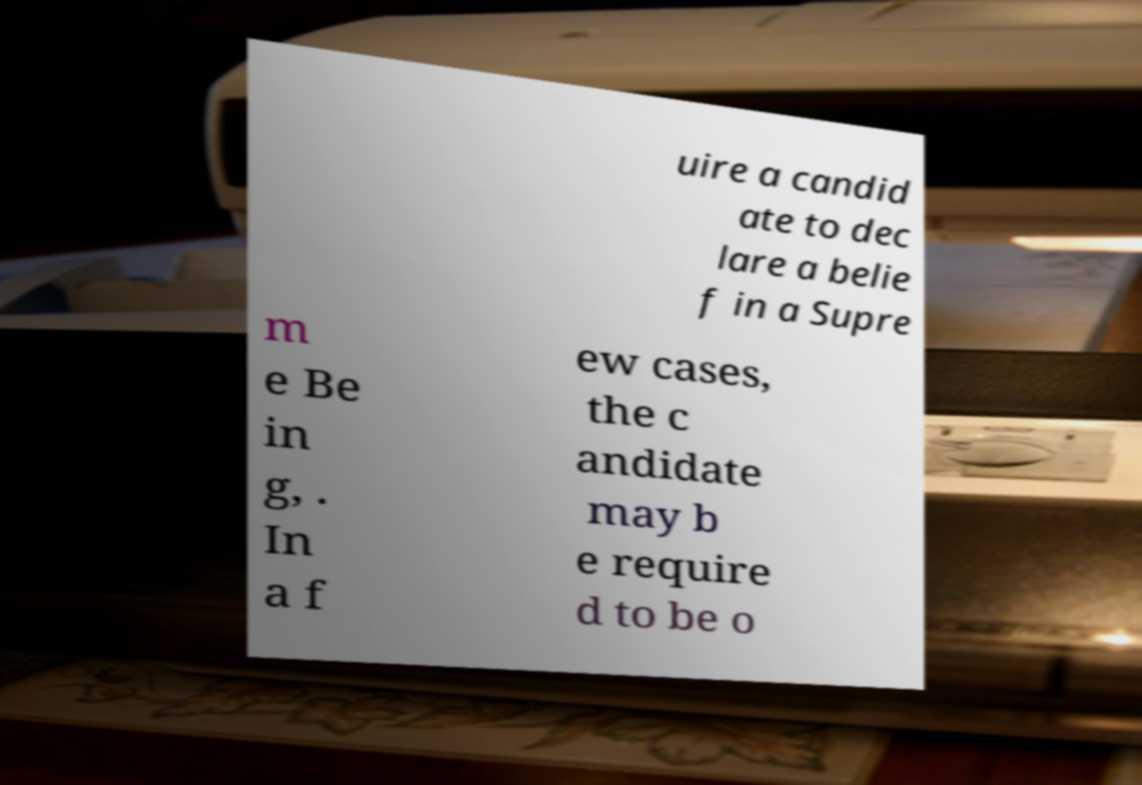I need the written content from this picture converted into text. Can you do that? uire a candid ate to dec lare a belie f in a Supre m e Be in g, . In a f ew cases, the c andidate may b e require d to be o 